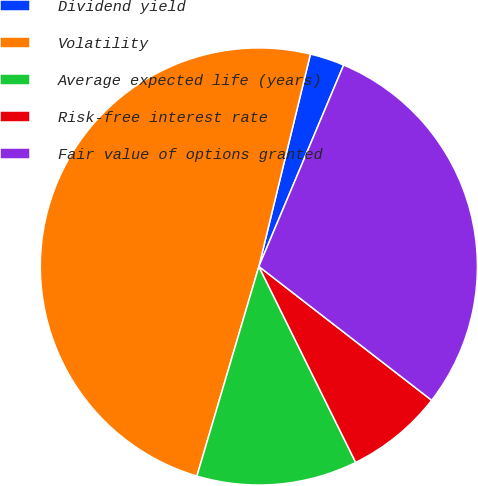<chart> <loc_0><loc_0><loc_500><loc_500><pie_chart><fcel>Dividend yield<fcel>Volatility<fcel>Average expected life (years)<fcel>Risk-free interest rate<fcel>Fair value of options granted<nl><fcel>2.55%<fcel>49.22%<fcel>11.88%<fcel>7.21%<fcel>29.15%<nl></chart> 